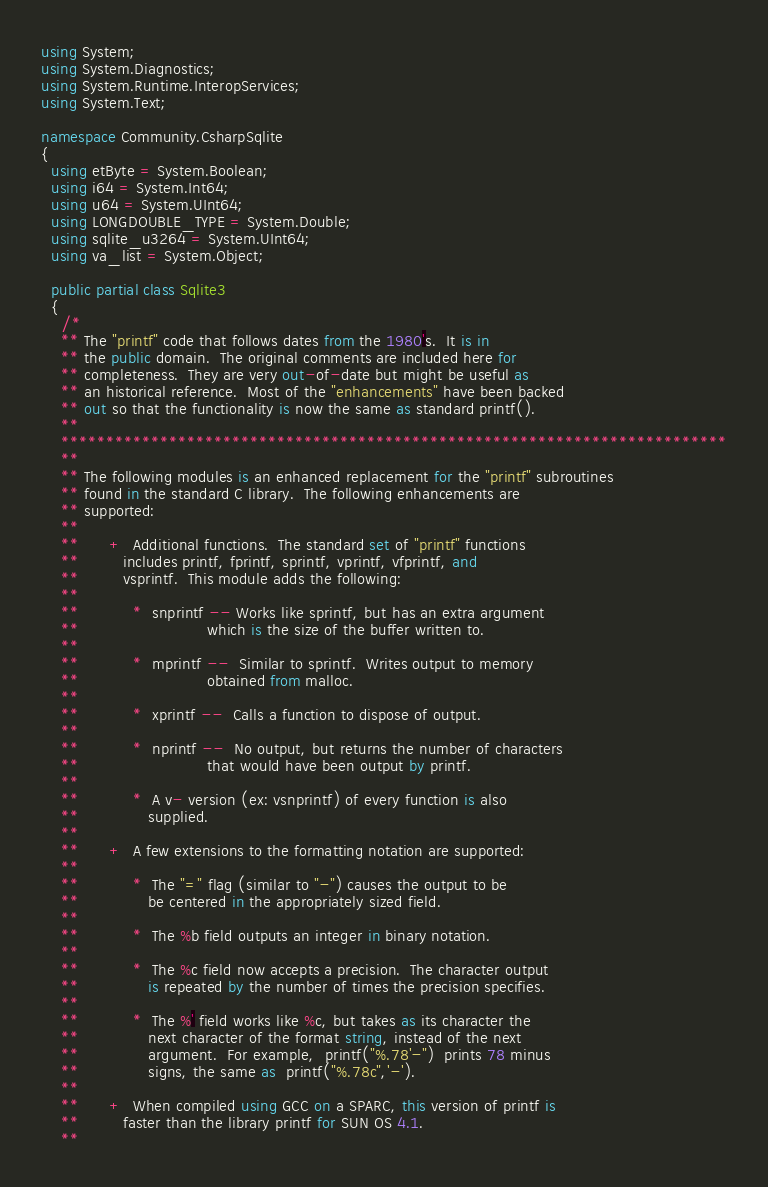<code> <loc_0><loc_0><loc_500><loc_500><_C#_>using System;
using System.Diagnostics;
using System.Runtime.InteropServices;
using System.Text;

namespace Community.CsharpSqlite
{
  using etByte = System.Boolean;
  using i64 = System.Int64;
  using u64 = System.UInt64;
  using LONGDOUBLE_TYPE = System.Double;
  using sqlite_u3264 = System.UInt64;
  using va_list = System.Object;

  public partial class Sqlite3
  {
    /*
    ** The "printf" code that follows dates from the 1980's.  It is in
    ** the public domain.  The original comments are included here for
    ** completeness.  They are very out-of-date but might be useful as
    ** an historical reference.  Most of the "enhancements" have been backed
    ** out so that the functionality is now the same as standard printf().
    **
    **************************************************************************
    **
    ** The following modules is an enhanced replacement for the "printf" subroutines
    ** found in the standard C library.  The following enhancements are
    ** supported:
    **
    **      +  Additional functions.  The standard set of "printf" functions
    **         includes printf, fprintf, sprintf, vprintf, vfprintf, and
    **         vsprintf.  This module adds the following:
    **
    **           *  snprintf -- Works like sprintf, but has an extra argument
    **                          which is the size of the buffer written to.
    **
    **           *  mprintf --  Similar to sprintf.  Writes output to memory
    **                          obtained from malloc.
    **
    **           *  xprintf --  Calls a function to dispose of output.
    **
    **           *  nprintf --  No output, but returns the number of characters
    **                          that would have been output by printf.
    **
    **           *  A v- version (ex: vsnprintf) of every function is also
    **              supplied.
    **
    **      +  A few extensions to the formatting notation are supported:
    **
    **           *  The "=" flag (similar to "-") causes the output to be
    **              be centered in the appropriately sized field.
    **
    **           *  The %b field outputs an integer in binary notation.
    **
    **           *  The %c field now accepts a precision.  The character output
    **              is repeated by the number of times the precision specifies.
    **
    **           *  The %' field works like %c, but takes as its character the
    **              next character of the format string, instead of the next
    **              argument.  For example,  printf("%.78'-")  prints 78 minus
    **              signs, the same as  printf("%.78c",'-').
    **
    **      +  When compiled using GCC on a SPARC, this version of printf is
    **         faster than the library printf for SUN OS 4.1.
    **</code> 